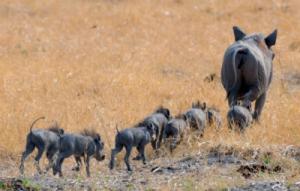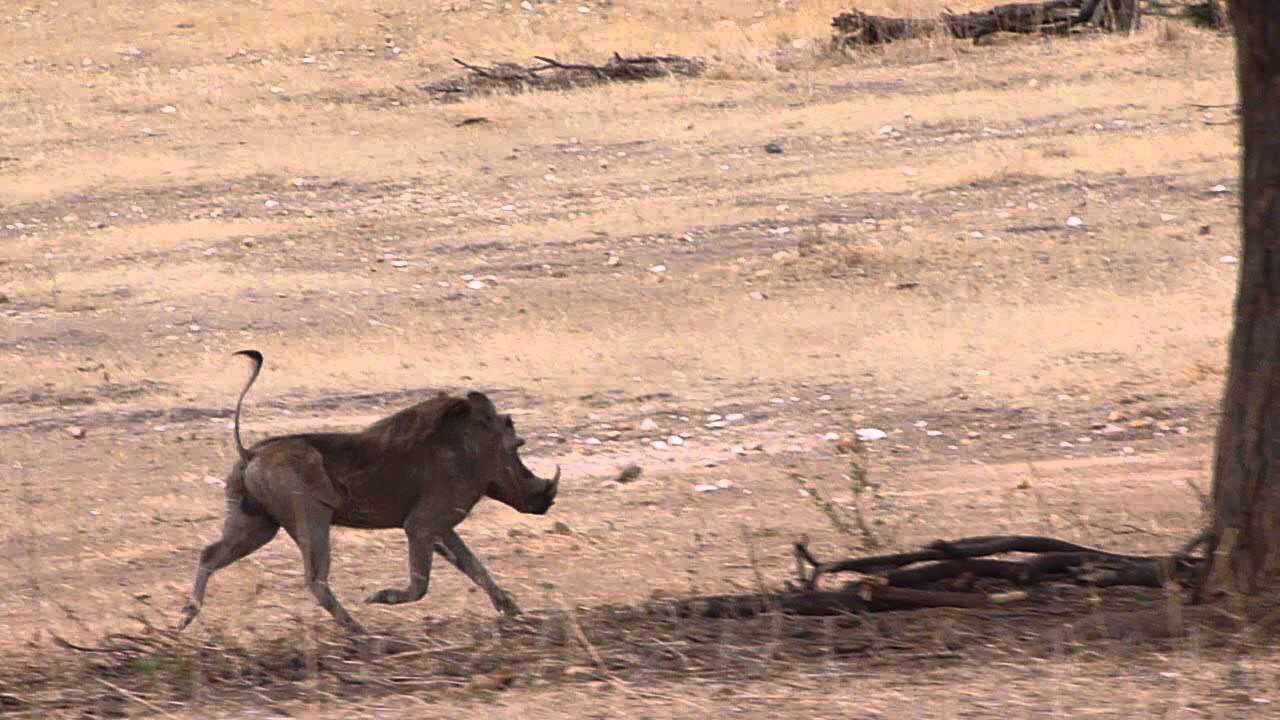The first image is the image on the left, the second image is the image on the right. For the images shown, is this caption "A mother hog leads a farrow of at least two facing the background." true? Answer yes or no. Yes. The first image is the image on the left, the second image is the image on the right. Given the left and right images, does the statement "At least one image shows animals running away from the camera." hold true? Answer yes or no. Yes. 